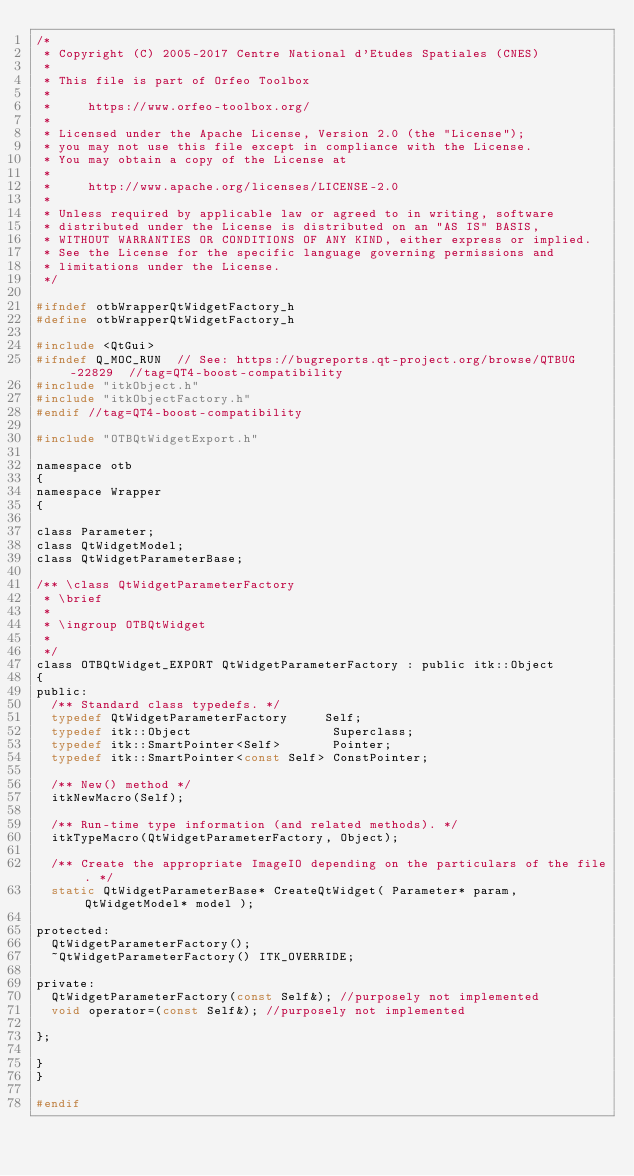Convert code to text. <code><loc_0><loc_0><loc_500><loc_500><_C_>/*
 * Copyright (C) 2005-2017 Centre National d'Etudes Spatiales (CNES)
 *
 * This file is part of Orfeo Toolbox
 *
 *     https://www.orfeo-toolbox.org/
 *
 * Licensed under the Apache License, Version 2.0 (the "License");
 * you may not use this file except in compliance with the License.
 * You may obtain a copy of the License at
 *
 *     http://www.apache.org/licenses/LICENSE-2.0
 *
 * Unless required by applicable law or agreed to in writing, software
 * distributed under the License is distributed on an "AS IS" BASIS,
 * WITHOUT WARRANTIES OR CONDITIONS OF ANY KIND, either express or implied.
 * See the License for the specific language governing permissions and
 * limitations under the License.
 */

#ifndef otbWrapperQtWidgetFactory_h
#define otbWrapperQtWidgetFactory_h

#include <QtGui>
#ifndef Q_MOC_RUN  // See: https://bugreports.qt-project.org/browse/QTBUG-22829  //tag=QT4-boost-compatibility
#include "itkObject.h"
#include "itkObjectFactory.h"
#endif //tag=QT4-boost-compatibility

#include "OTBQtWidgetExport.h"

namespace otb
{
namespace Wrapper
{

class Parameter;
class QtWidgetModel;
class QtWidgetParameterBase;

/** \class QtWidgetParameterFactory
 * \brief
 *
 * \ingroup OTBQtWidget
 *
 */
class OTBQtWidget_EXPORT QtWidgetParameterFactory : public itk::Object
{
public:
  /** Standard class typedefs. */
  typedef QtWidgetParameterFactory     Self;
  typedef itk::Object                   Superclass;
  typedef itk::SmartPointer<Self>       Pointer;
  typedef itk::SmartPointer<const Self> ConstPointer;

  /** New() method */
  itkNewMacro(Self);

  /** Run-time type information (and related methods). */
  itkTypeMacro(QtWidgetParameterFactory, Object);

  /** Create the appropriate ImageIO depending on the particulars of the file. */
  static QtWidgetParameterBase* CreateQtWidget( Parameter* param, QtWidgetModel* model );

protected:
  QtWidgetParameterFactory();
  ~QtWidgetParameterFactory() ITK_OVERRIDE;

private:
  QtWidgetParameterFactory(const Self&); //purposely not implemented
  void operator=(const Self&); //purposely not implemented

};

}
}

#endif
</code> 